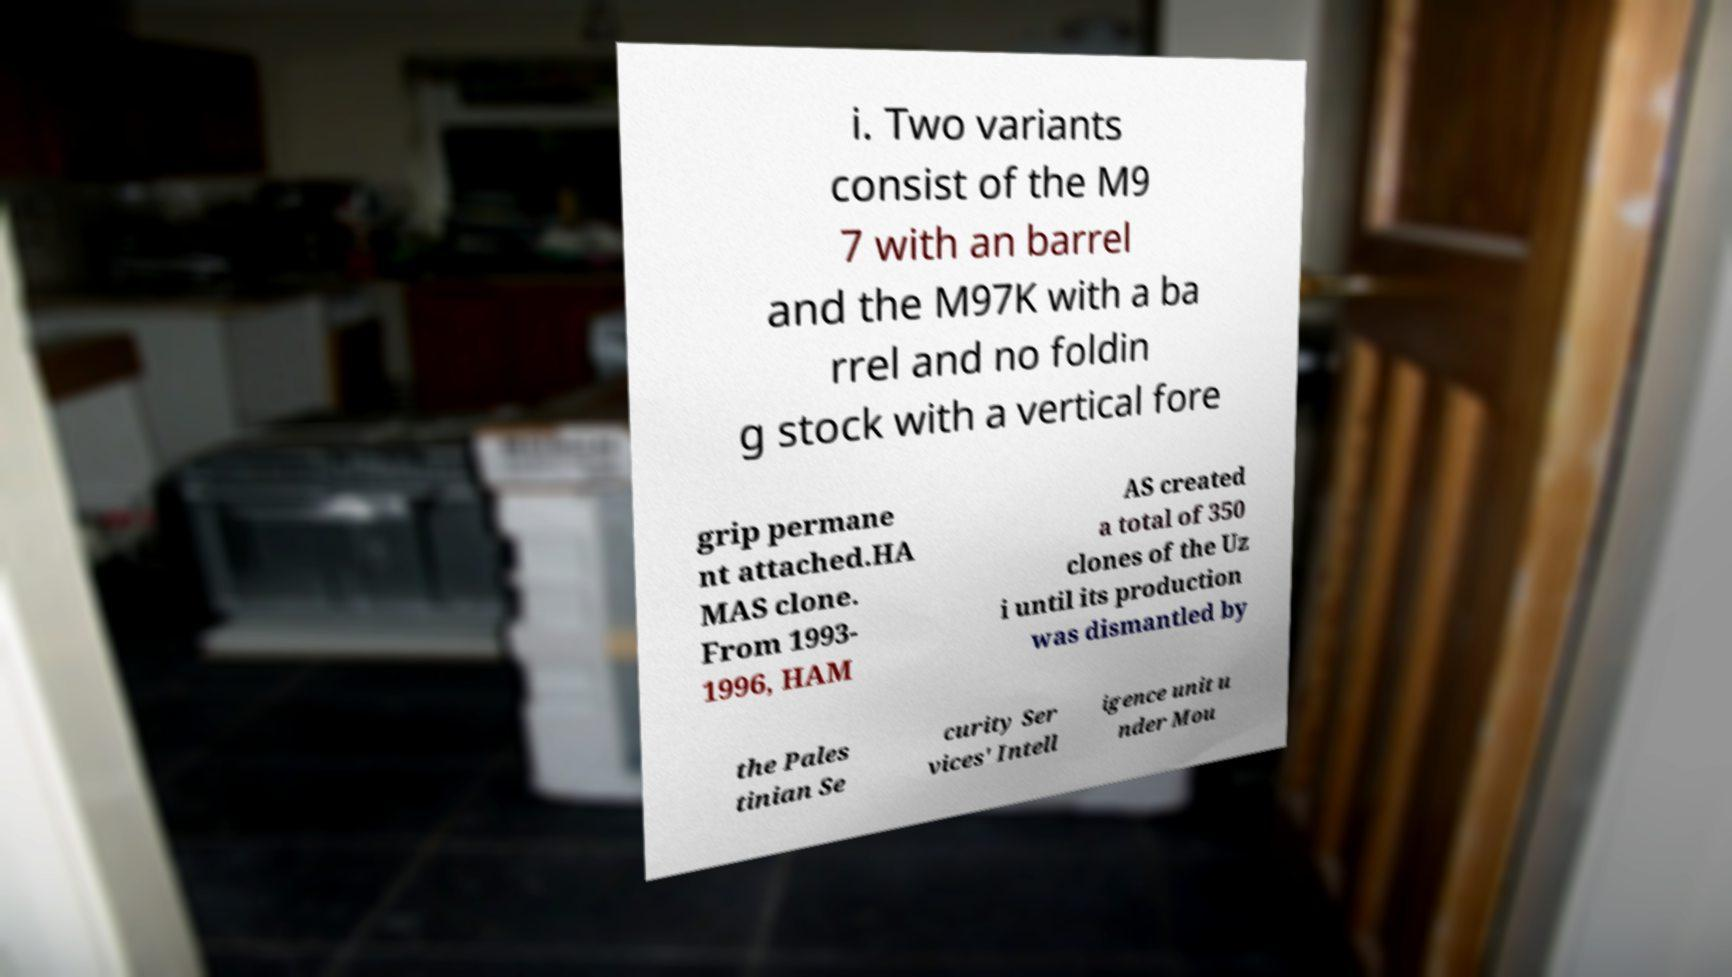For documentation purposes, I need the text within this image transcribed. Could you provide that? i. Two variants consist of the M9 7 with an barrel and the M97K with a ba rrel and no foldin g stock with a vertical fore grip permane nt attached.HA MAS clone. From 1993- 1996, HAM AS created a total of 350 clones of the Uz i until its production was dismantled by the Pales tinian Se curity Ser vices' Intell igence unit u nder Mou 